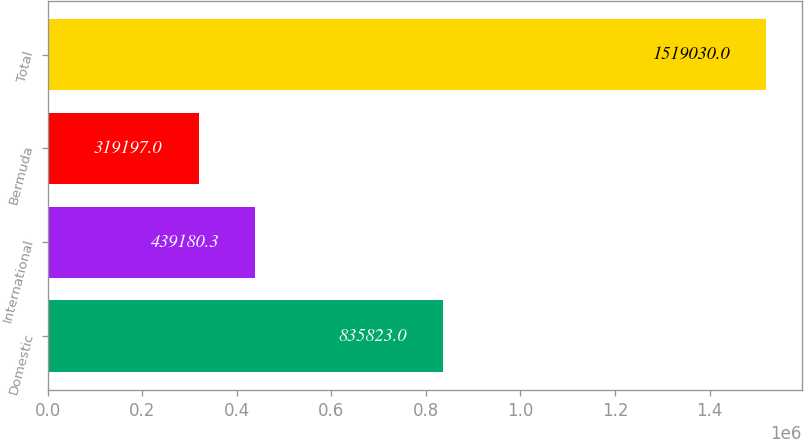Convert chart to OTSL. <chart><loc_0><loc_0><loc_500><loc_500><bar_chart><fcel>Domestic<fcel>International<fcel>Bermuda<fcel>Total<nl><fcel>835823<fcel>439180<fcel>319197<fcel>1.51903e+06<nl></chart> 